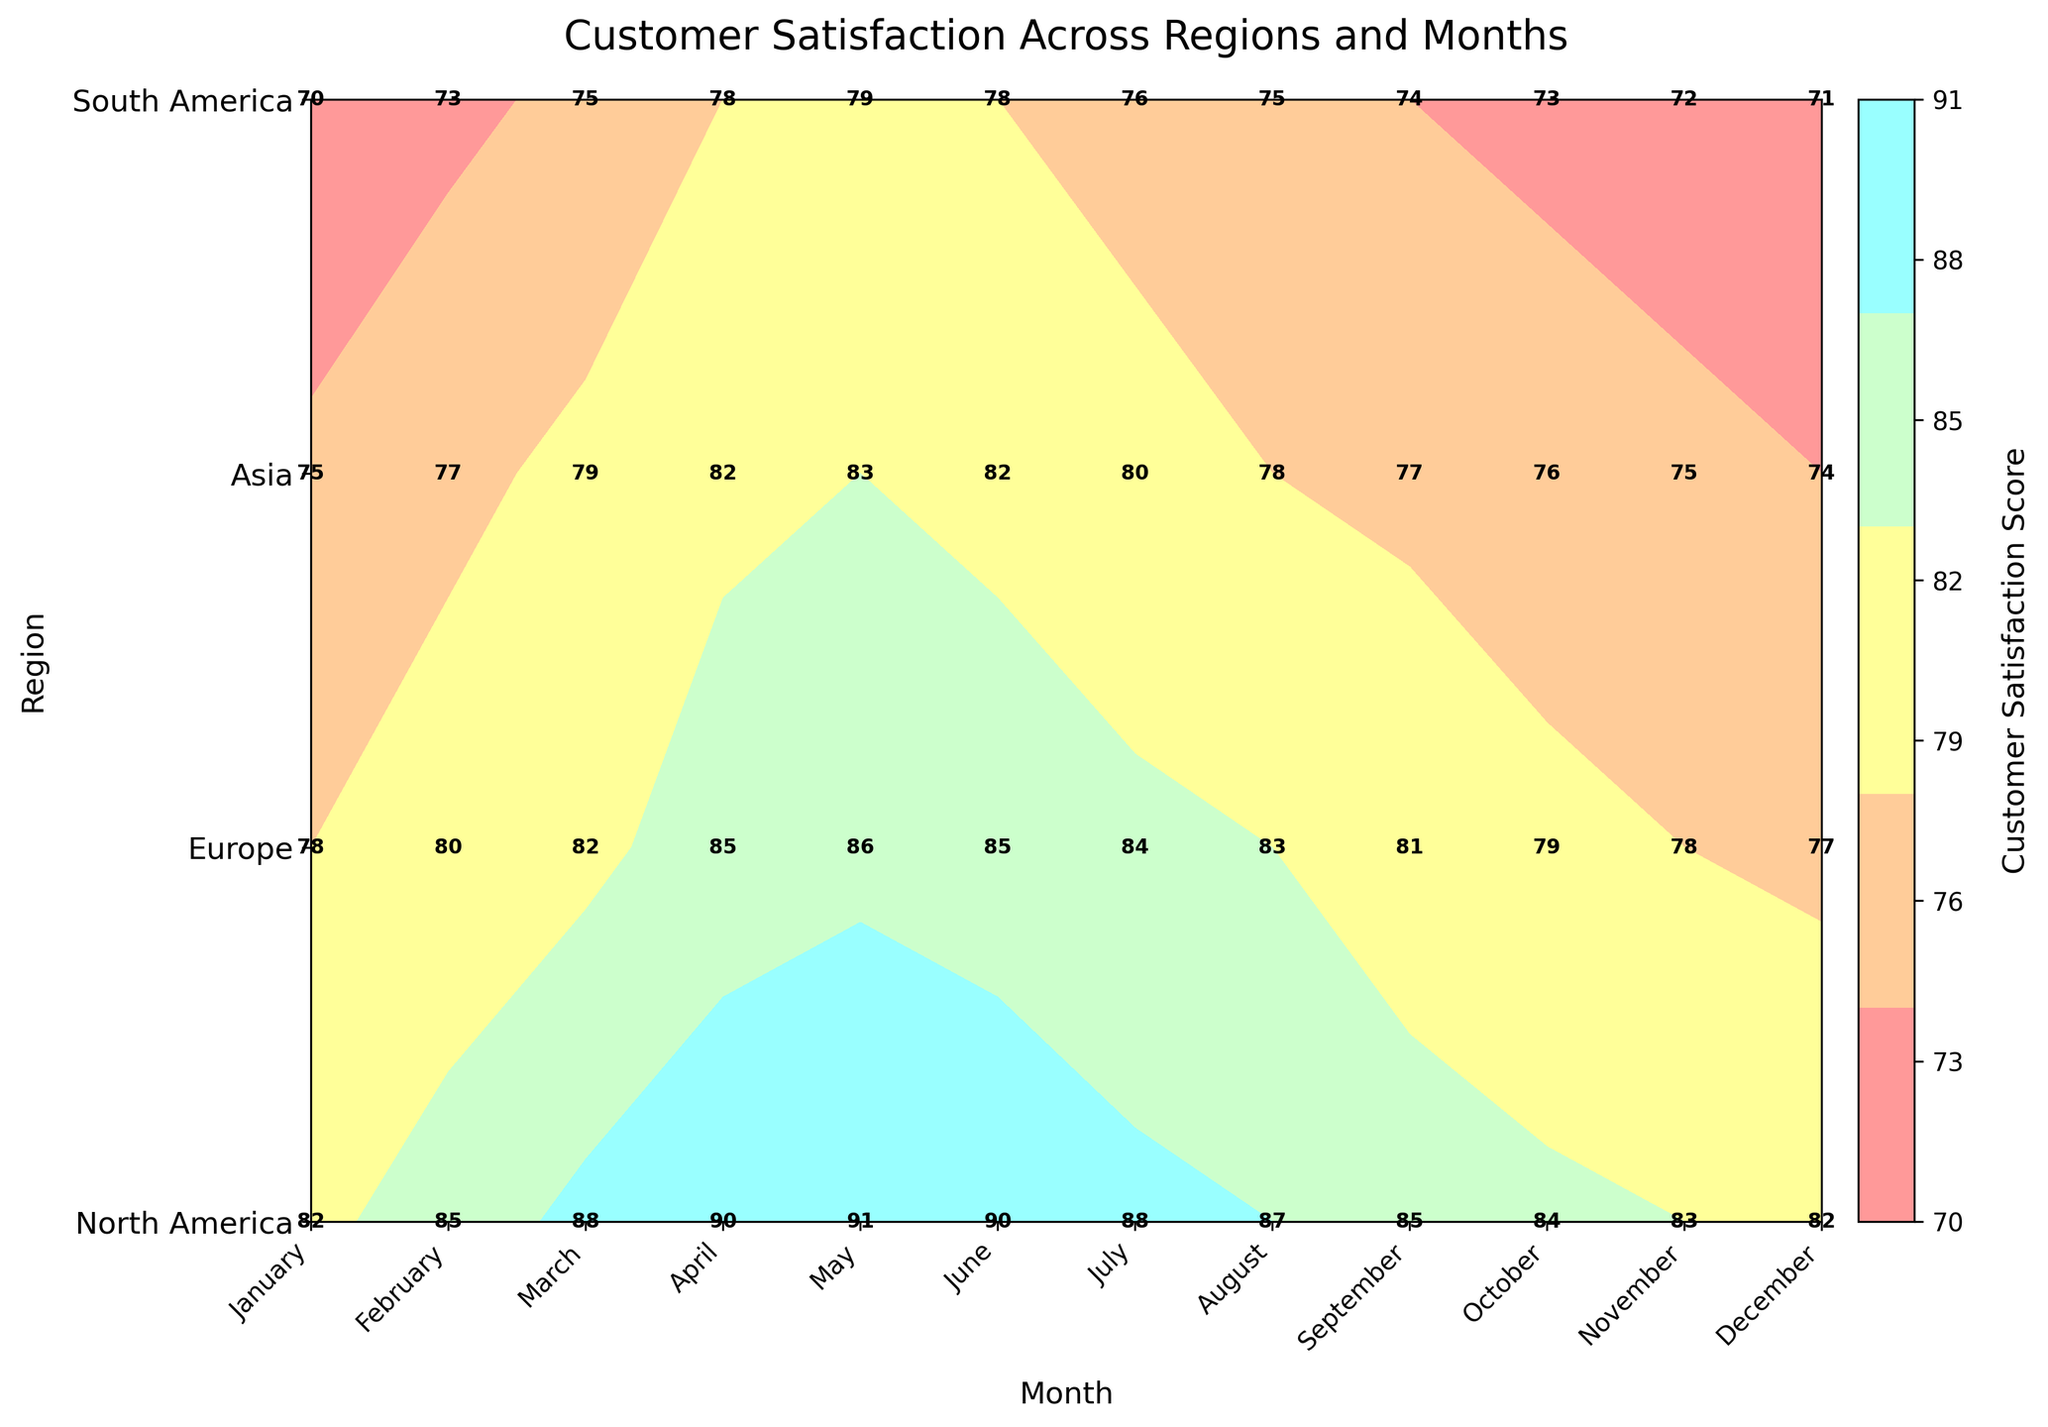What is the title of the plot? The title of the plot appears at the top, usually in a larger and bolder font compared to other text elements. In this case, the title clearly reads "Customer Satisfaction Across Regions and Months" which gives an overview of what the plot is about.
Answer: Customer Satisfaction Across Regions and Months How many regions are represented in the plot? To determine the number of regions, one should look at the y-axis, which lists all the regions. By counting the unique labels, it can be observed that there are four regions: North America, Europe, Asia, and South America.
Answer: 4 Which region has the highest customer satisfaction score in April? To find this, locate the month of April along the x-axis and then look at the contour levels or direct annotations within that column to find the highest value. North America has an annotation of 90, which is the highest.
Answer: North America What's the average customer satisfaction score for North America over the year? Identify the customer satisfaction scores for North America across all months and sum them up. The scores are: 82, 85, 88, 90, 91, 90, 88, 87, 85, 84, 83, 82. The sum is 1035, and there are 12 data points, so the average is 1035 / 12.
Answer: 86.25 Which month generally has the highest customer satisfaction across all regions? Look for the column with the highest general customer satisfaction scores across all regions. Both May and April have relatively higher satisfaction scores in most regions compared to other months, but May slightly edges out with higher scores overall.
Answer: May How does customer satisfaction in Asia compare between January and December? Find the scores for Asia in January and December along the y-axis under these columns. January has a score of 75, and December has a score of 74, indicating almost no change.
Answer: Comparable Which region shows the greatest increase in customer satisfaction from January to June? Examine the scores for each region in January and June, then calculate the difference for each region. North America increases from 82 to 90 (an 8-point increase); Europe goes from 78 to 85 (a 7-point increase); Asia goes from 75 to 82 (a 7-point increase); South America goes from 70 to 78 (an 8-point increase). Both North America and South America show an 8-point increase.
Answer: North America and South America Is there any region that shows a consistent increase in customer satisfaction from January to December? Check the trend of customer satisfaction scores in each region month-by-month from January to December. None of the regions show a consistent increase throughout the year as there are fluctuations in all regions.
Answer: No What is the customer satisfaction score for Europe in October? To find the score for Europe in October, locate October on the x-axis and Europe on the y-axis. The annotated score in the cell corresponds to 79.
Answer: 79 